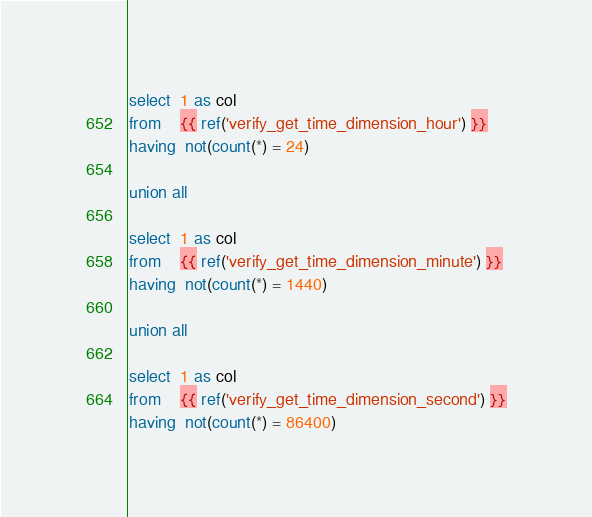<code> <loc_0><loc_0><loc_500><loc_500><_SQL_>select  1 as col
from    {{ ref('verify_get_time_dimension_hour') }}
having  not(count(*) = 24)

union all

select  1 as col
from    {{ ref('verify_get_time_dimension_minute') }}
having  not(count(*) = 1440)

union all

select  1 as col
from    {{ ref('verify_get_time_dimension_second') }}
having  not(count(*) = 86400)</code> 